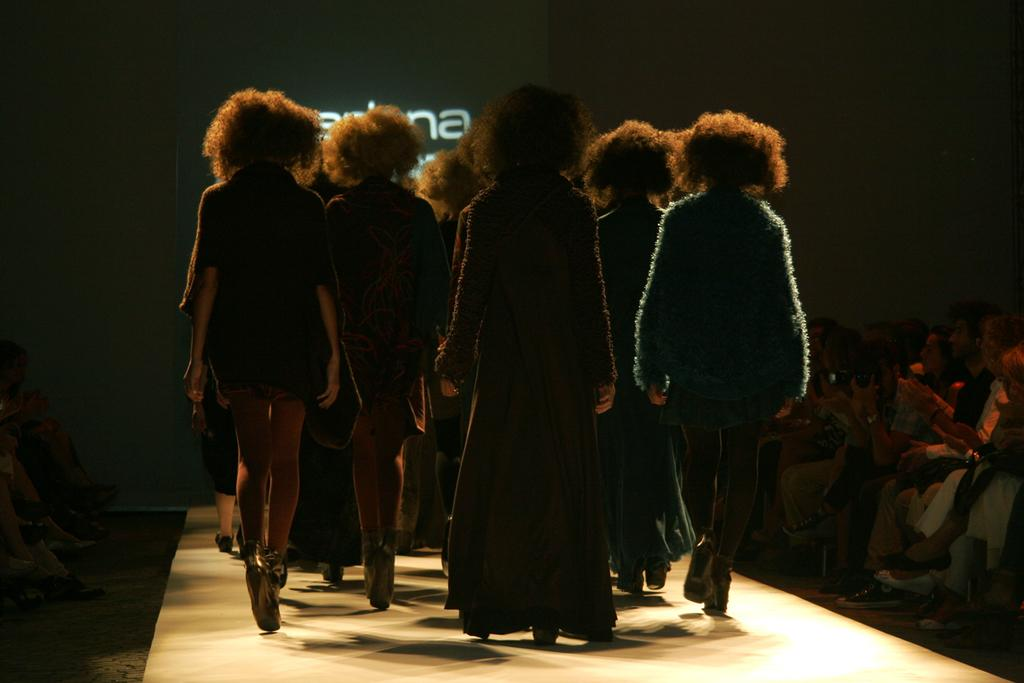What are the people in the image doing? There are people walking and sitting in the image. Can you describe the background of the image? The background of the image is dark. What can be seen in the background of the image? There is a screen visible in the background. What type of basin is being used by the people in the image? There is no basin present in the image. What color is the coat worn by the people in the image? There is no coat visible in the image. 